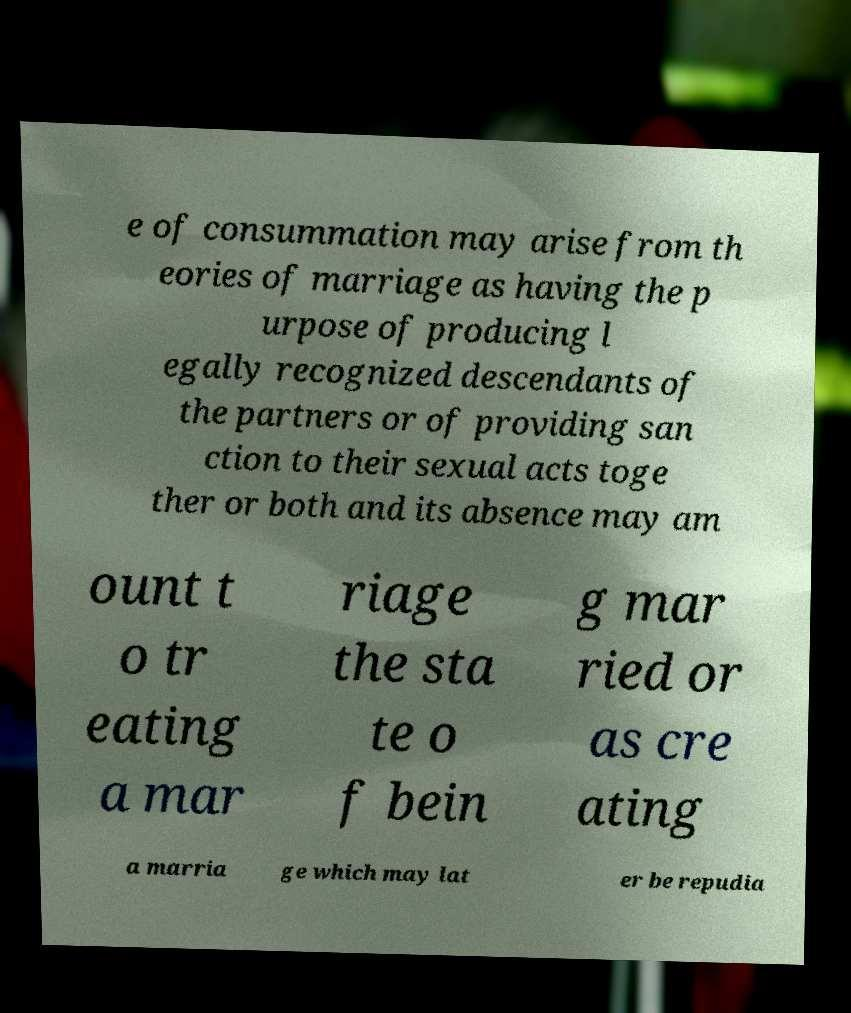For documentation purposes, I need the text within this image transcribed. Could you provide that? e of consummation may arise from th eories of marriage as having the p urpose of producing l egally recognized descendants of the partners or of providing san ction to their sexual acts toge ther or both and its absence may am ount t o tr eating a mar riage the sta te o f bein g mar ried or as cre ating a marria ge which may lat er be repudia 